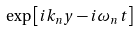<formula> <loc_0><loc_0><loc_500><loc_500>\exp \left [ i k _ { n } y - i \omega _ { n } t \right ]</formula> 